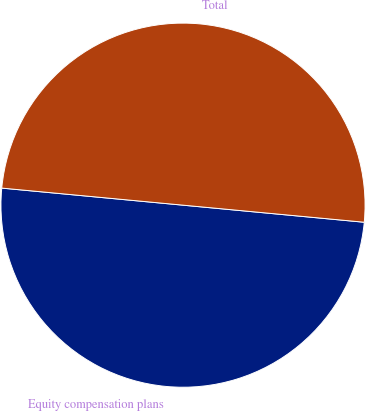Convert chart to OTSL. <chart><loc_0><loc_0><loc_500><loc_500><pie_chart><fcel>Equity compensation plans<fcel>Total<nl><fcel>50.0%<fcel>50.0%<nl></chart> 